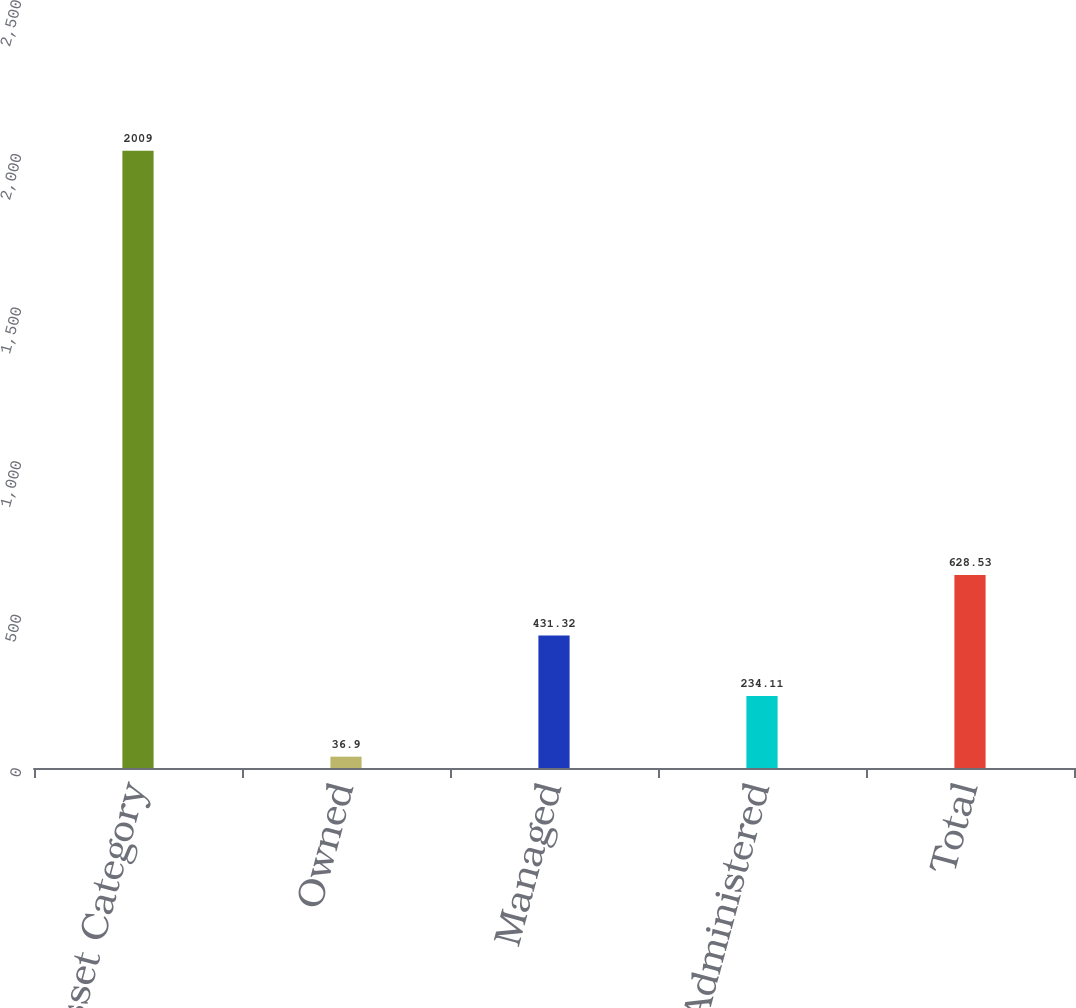<chart> <loc_0><loc_0><loc_500><loc_500><bar_chart><fcel>Asset Category<fcel>Owned<fcel>Managed<fcel>Administered<fcel>Total<nl><fcel>2009<fcel>36.9<fcel>431.32<fcel>234.11<fcel>628.53<nl></chart> 